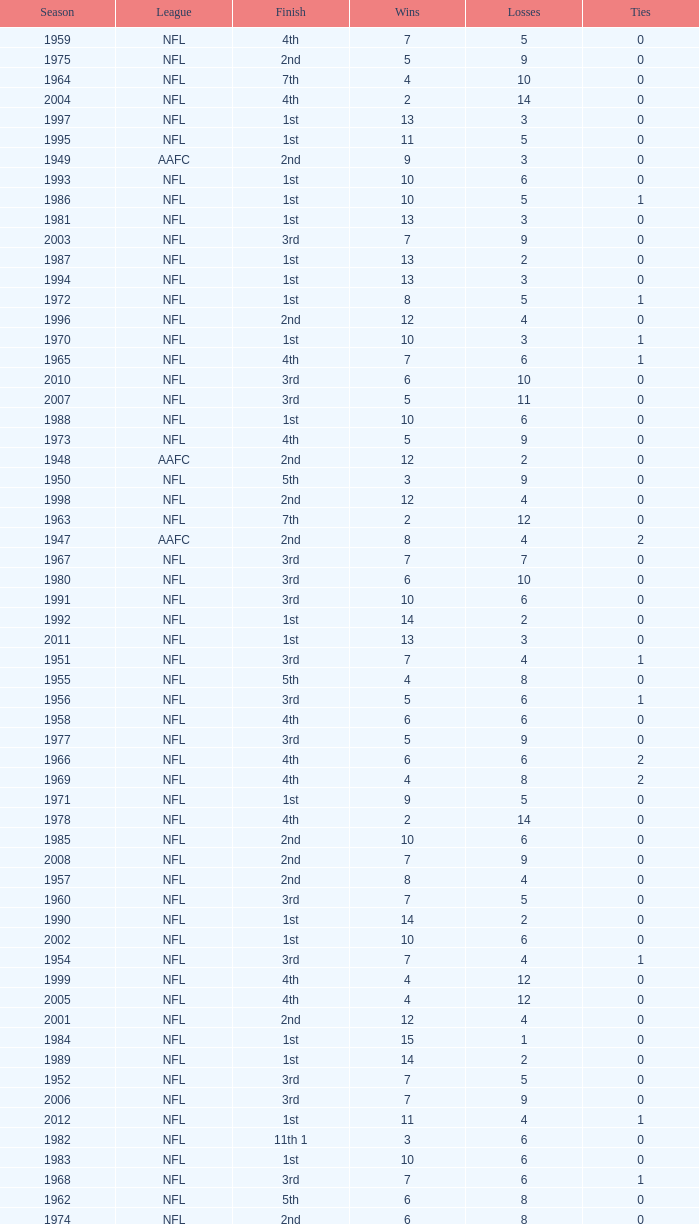What is the losses in the NFL in the 2011 season with less than 13 wins? None. 